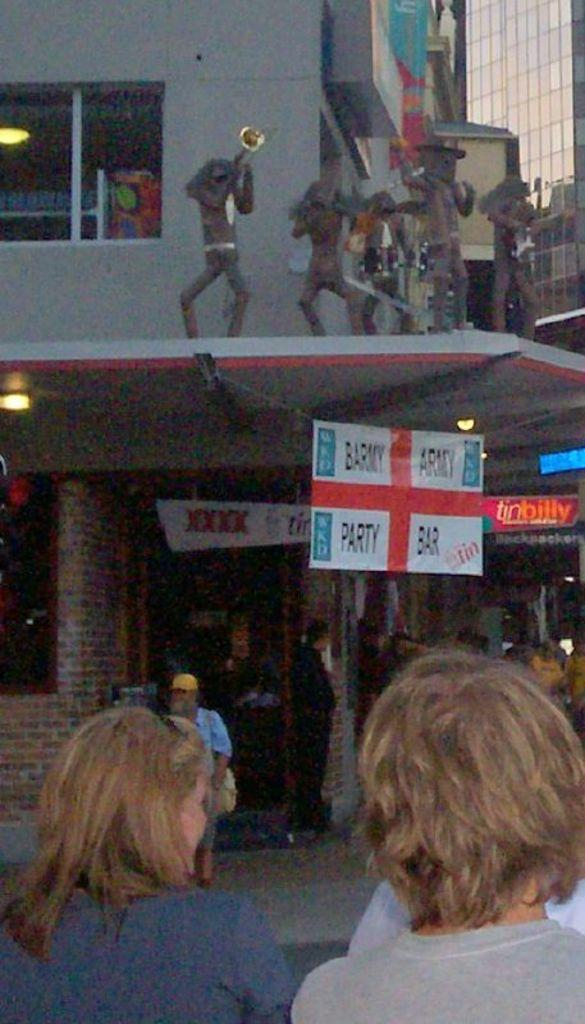Who or what can be seen in the image? There are persons and statues in the image. What else is present in the image besides people and statues? There are boards, lights, and buildings in the image. What time of day is it in the image, and what are the persons doing in their offices? The provided facts do not mention the time of day or any offices, so we cannot determine the time or the activities of the persons in the image. 